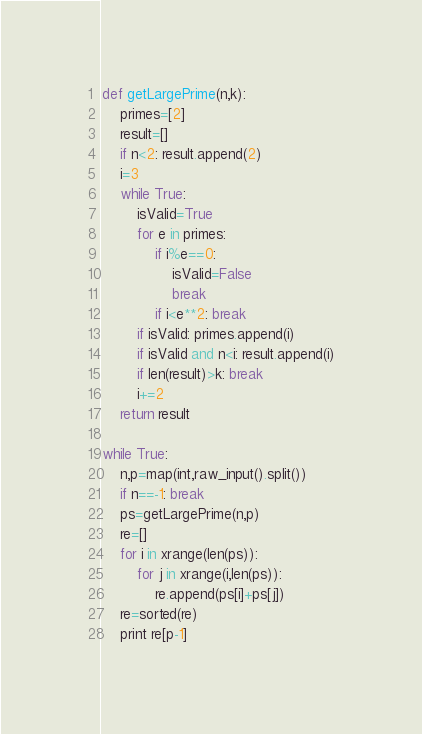Convert code to text. <code><loc_0><loc_0><loc_500><loc_500><_Python_>def getLargePrime(n,k):
    primes=[2]
    result=[]
    if n<2: result.append(2)
    i=3
    while True:
        isValid=True
        for e in primes:
            if i%e==0:
                isValid=False
                break
            if i<e**2: break
        if isValid: primes.append(i)
        if isValid and n<i: result.append(i)
        if len(result)>k: break
        i+=2
    return result

while True:
    n,p=map(int,raw_input().split())
    if n==-1: break
    ps=getLargePrime(n,p)
    re=[]
    for i in xrange(len(ps)):
        for j in xrange(i,len(ps)):
            re.append(ps[i]+ps[j])
    re=sorted(re)
    print re[p-1]</code> 